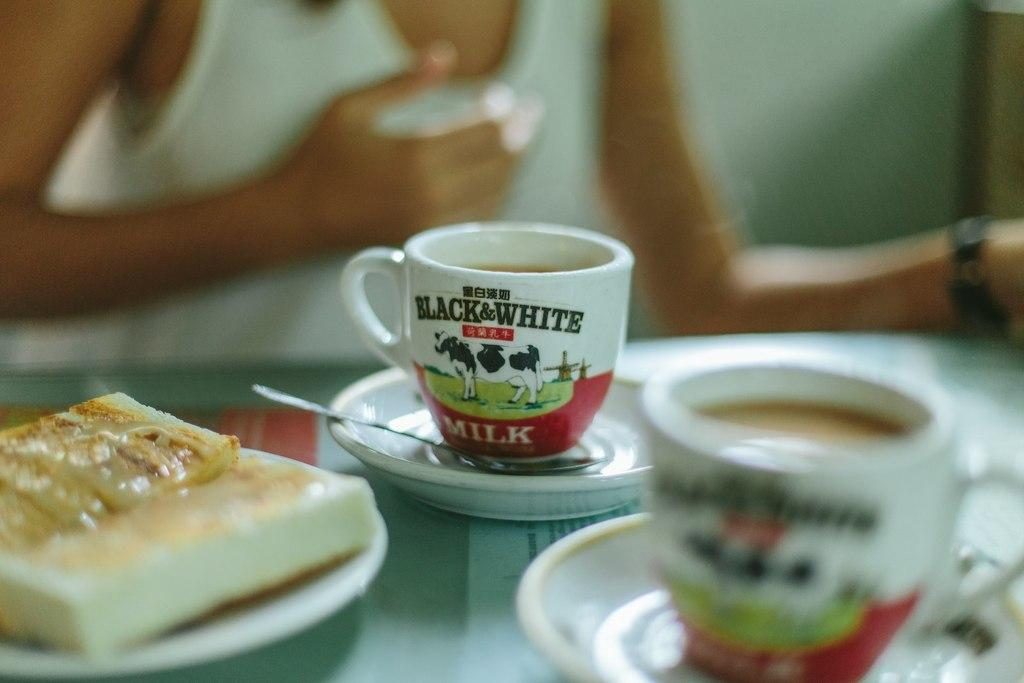What is the main object in the image? There is a table in the image. What is on the table? The table contains a plate with food and cups with saucers. Can you describe the person in the background of the image? There is a person in the background of the image, but their face is not visible. What type of leaf is being used as a design element on the plate? There is no leaf present on the plate in the image. Can you tell me how many gravestones are visible in the cemetery in the image? There is no cemetery present in the image; it features a table with food and cups. 